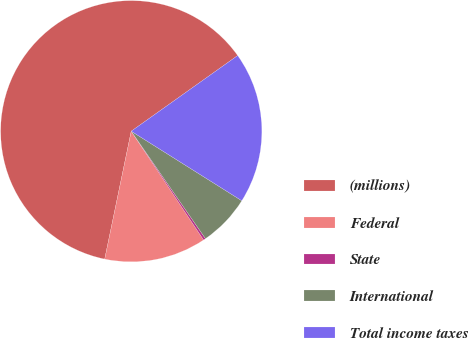<chart> <loc_0><loc_0><loc_500><loc_500><pie_chart><fcel>(millions)<fcel>Federal<fcel>State<fcel>International<fcel>Total income taxes<nl><fcel>61.91%<fcel>12.6%<fcel>0.28%<fcel>6.44%<fcel>18.77%<nl></chart> 